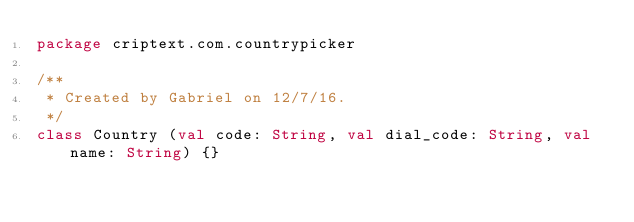<code> <loc_0><loc_0><loc_500><loc_500><_Kotlin_>package criptext.com.countrypicker

/**
 * Created by Gabriel on 12/7/16.
 */
class Country (val code: String, val dial_code: String, val name: String) {}
</code> 